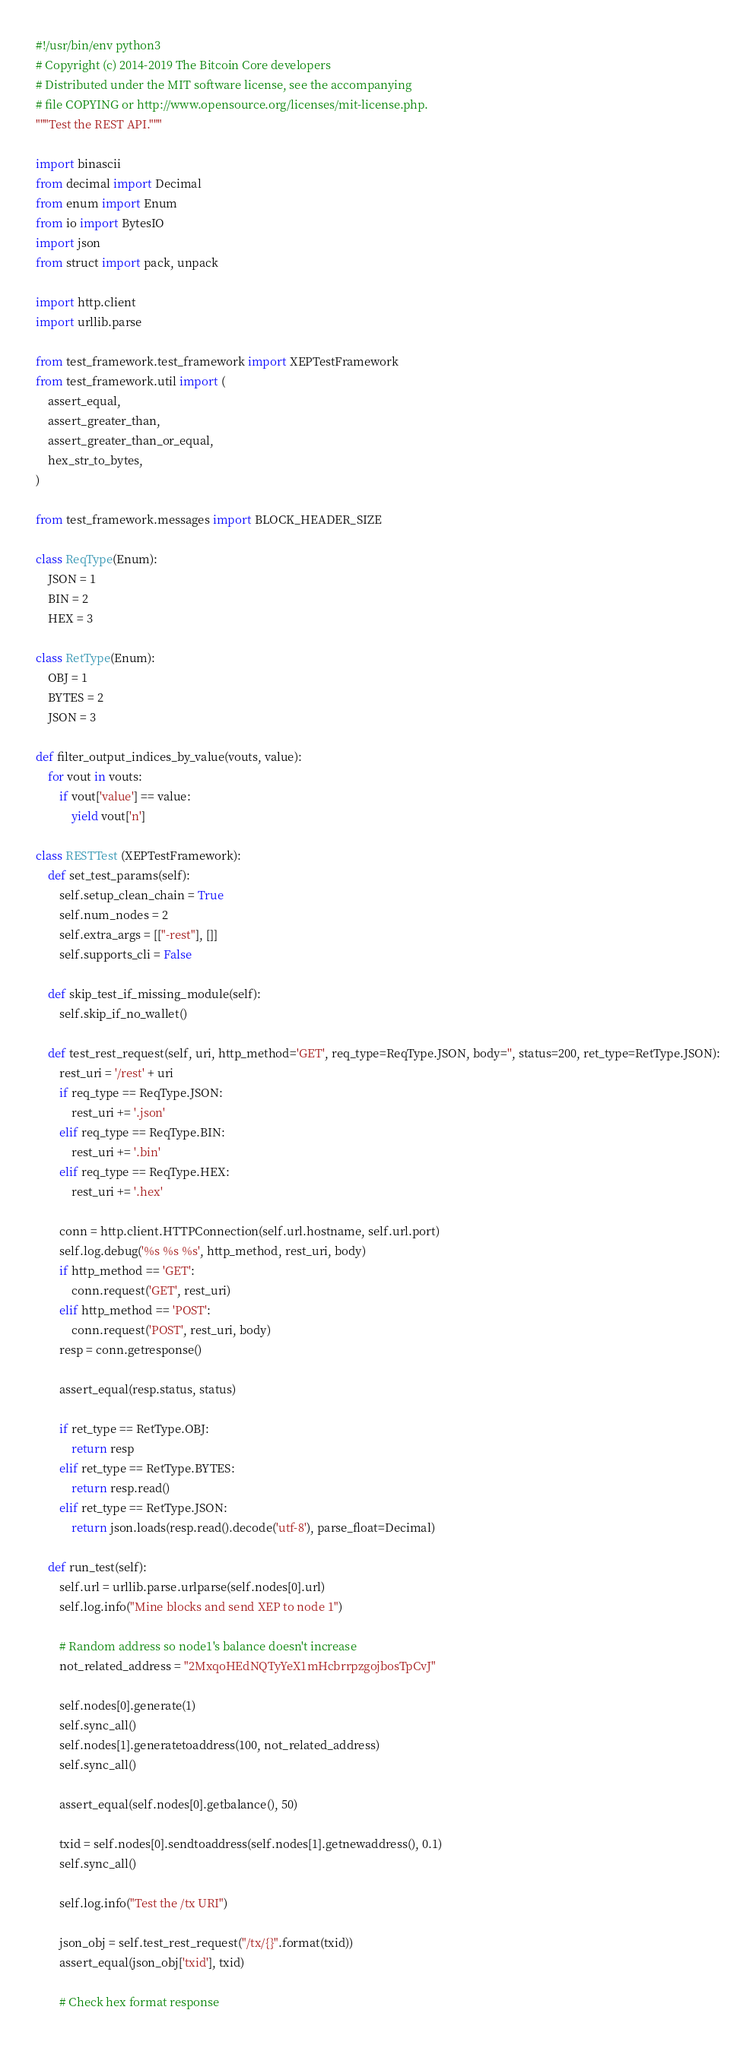Convert code to text. <code><loc_0><loc_0><loc_500><loc_500><_Python_>#!/usr/bin/env python3
# Copyright (c) 2014-2019 The Bitcoin Core developers
# Distributed under the MIT software license, see the accompanying
# file COPYING or http://www.opensource.org/licenses/mit-license.php.
"""Test the REST API."""

import binascii
from decimal import Decimal
from enum import Enum
from io import BytesIO
import json
from struct import pack, unpack

import http.client
import urllib.parse

from test_framework.test_framework import XEPTestFramework
from test_framework.util import (
    assert_equal,
    assert_greater_than,
    assert_greater_than_or_equal,
    hex_str_to_bytes,
)

from test_framework.messages import BLOCK_HEADER_SIZE

class ReqType(Enum):
    JSON = 1
    BIN = 2
    HEX = 3

class RetType(Enum):
    OBJ = 1
    BYTES = 2
    JSON = 3

def filter_output_indices_by_value(vouts, value):
    for vout in vouts:
        if vout['value'] == value:
            yield vout['n']

class RESTTest (XEPTestFramework):
    def set_test_params(self):
        self.setup_clean_chain = True
        self.num_nodes = 2
        self.extra_args = [["-rest"], []]
        self.supports_cli = False

    def skip_test_if_missing_module(self):
        self.skip_if_no_wallet()

    def test_rest_request(self, uri, http_method='GET', req_type=ReqType.JSON, body='', status=200, ret_type=RetType.JSON):
        rest_uri = '/rest' + uri
        if req_type == ReqType.JSON:
            rest_uri += '.json'
        elif req_type == ReqType.BIN:
            rest_uri += '.bin'
        elif req_type == ReqType.HEX:
            rest_uri += '.hex'

        conn = http.client.HTTPConnection(self.url.hostname, self.url.port)
        self.log.debug('%s %s %s', http_method, rest_uri, body)
        if http_method == 'GET':
            conn.request('GET', rest_uri)
        elif http_method == 'POST':
            conn.request('POST', rest_uri, body)
        resp = conn.getresponse()

        assert_equal(resp.status, status)

        if ret_type == RetType.OBJ:
            return resp
        elif ret_type == RetType.BYTES:
            return resp.read()
        elif ret_type == RetType.JSON:
            return json.loads(resp.read().decode('utf-8'), parse_float=Decimal)

    def run_test(self):
        self.url = urllib.parse.urlparse(self.nodes[0].url)
        self.log.info("Mine blocks and send XEP to node 1")

        # Random address so node1's balance doesn't increase
        not_related_address = "2MxqoHEdNQTyYeX1mHcbrrpzgojbosTpCvJ"

        self.nodes[0].generate(1)
        self.sync_all()
        self.nodes[1].generatetoaddress(100, not_related_address)
        self.sync_all()

        assert_equal(self.nodes[0].getbalance(), 50)

        txid = self.nodes[0].sendtoaddress(self.nodes[1].getnewaddress(), 0.1)
        self.sync_all()

        self.log.info("Test the /tx URI")

        json_obj = self.test_rest_request("/tx/{}".format(txid))
        assert_equal(json_obj['txid'], txid)

        # Check hex format response</code> 